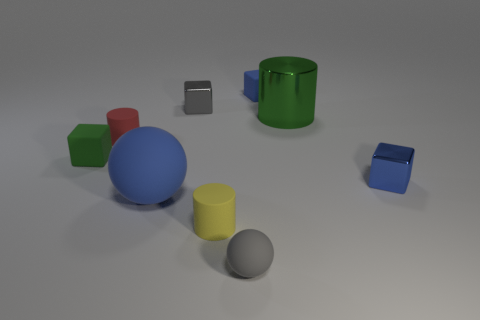Subtract all tiny gray metal blocks. How many blocks are left? 3 Subtract 2 blocks. How many blocks are left? 2 Subtract all gray balls. How many balls are left? 1 Subtract all gray balls. How many green blocks are left? 1 Subtract all green cylinders. Subtract all blue cubes. How many cylinders are left? 2 Subtract all balls. How many objects are left? 7 Subtract all green cubes. Subtract all big brown matte blocks. How many objects are left? 8 Add 8 gray spheres. How many gray spheres are left? 9 Add 7 tiny rubber spheres. How many tiny rubber spheres exist? 8 Subtract 0 brown cubes. How many objects are left? 9 